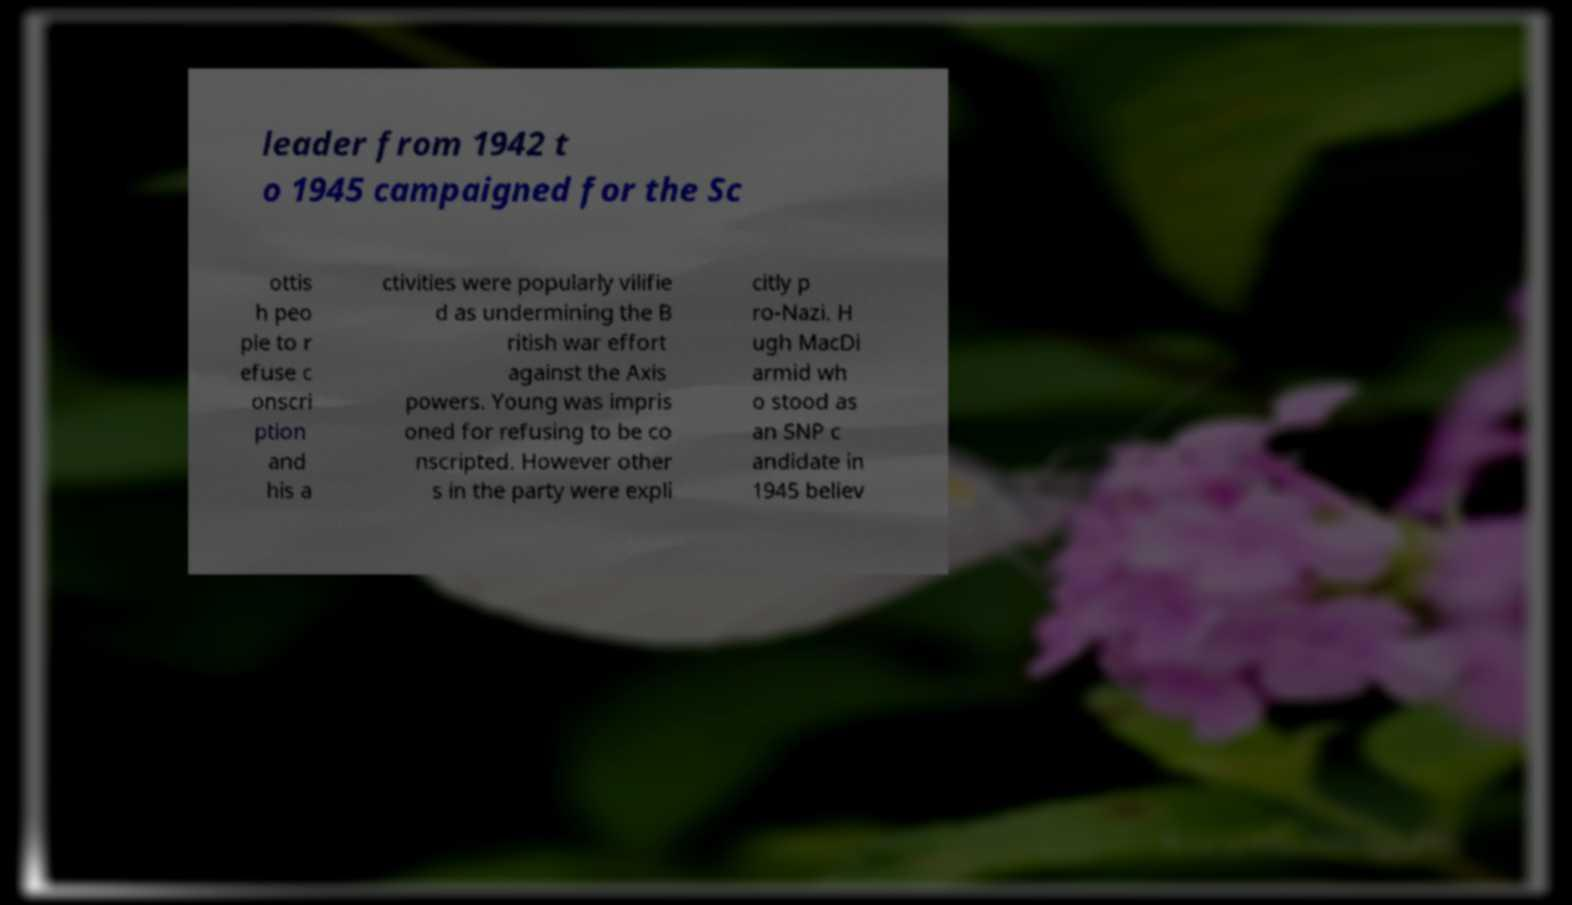Can you accurately transcribe the text from the provided image for me? leader from 1942 t o 1945 campaigned for the Sc ottis h peo ple to r efuse c onscri ption and his a ctivities were popularly vilifie d as undermining the B ritish war effort against the Axis powers. Young was impris oned for refusing to be co nscripted. However other s in the party were expli citly p ro-Nazi. H ugh MacDi armid wh o stood as an SNP c andidate in 1945 believ 